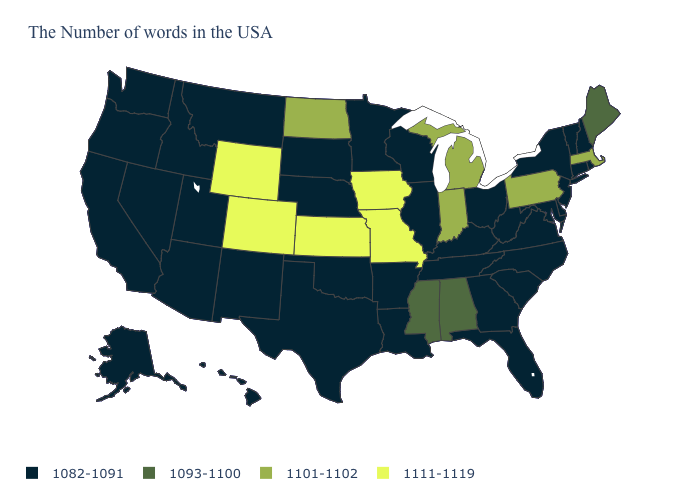What is the value of North Dakota?
Quick response, please. 1101-1102. Among the states that border New Hampshire , does Maine have the lowest value?
Write a very short answer. No. Which states have the lowest value in the USA?
Short answer required. Rhode Island, New Hampshire, Vermont, Connecticut, New York, New Jersey, Delaware, Maryland, Virginia, North Carolina, South Carolina, West Virginia, Ohio, Florida, Georgia, Kentucky, Tennessee, Wisconsin, Illinois, Louisiana, Arkansas, Minnesota, Nebraska, Oklahoma, Texas, South Dakota, New Mexico, Utah, Montana, Arizona, Idaho, Nevada, California, Washington, Oregon, Alaska, Hawaii. Does the first symbol in the legend represent the smallest category?
Give a very brief answer. Yes. What is the value of Alaska?
Keep it brief. 1082-1091. What is the value of Illinois?
Keep it brief. 1082-1091. Which states have the lowest value in the USA?
Be succinct. Rhode Island, New Hampshire, Vermont, Connecticut, New York, New Jersey, Delaware, Maryland, Virginia, North Carolina, South Carolina, West Virginia, Ohio, Florida, Georgia, Kentucky, Tennessee, Wisconsin, Illinois, Louisiana, Arkansas, Minnesota, Nebraska, Oklahoma, Texas, South Dakota, New Mexico, Utah, Montana, Arizona, Idaho, Nevada, California, Washington, Oregon, Alaska, Hawaii. What is the value of Washington?
Keep it brief. 1082-1091. Name the states that have a value in the range 1082-1091?
Short answer required. Rhode Island, New Hampshire, Vermont, Connecticut, New York, New Jersey, Delaware, Maryland, Virginia, North Carolina, South Carolina, West Virginia, Ohio, Florida, Georgia, Kentucky, Tennessee, Wisconsin, Illinois, Louisiana, Arkansas, Minnesota, Nebraska, Oklahoma, Texas, South Dakota, New Mexico, Utah, Montana, Arizona, Idaho, Nevada, California, Washington, Oregon, Alaska, Hawaii. Which states hav the highest value in the Northeast?
Quick response, please. Massachusetts, Pennsylvania. Name the states that have a value in the range 1082-1091?
Concise answer only. Rhode Island, New Hampshire, Vermont, Connecticut, New York, New Jersey, Delaware, Maryland, Virginia, North Carolina, South Carolina, West Virginia, Ohio, Florida, Georgia, Kentucky, Tennessee, Wisconsin, Illinois, Louisiana, Arkansas, Minnesota, Nebraska, Oklahoma, Texas, South Dakota, New Mexico, Utah, Montana, Arizona, Idaho, Nevada, California, Washington, Oregon, Alaska, Hawaii. Name the states that have a value in the range 1101-1102?
Quick response, please. Massachusetts, Pennsylvania, Michigan, Indiana, North Dakota. What is the value of Washington?
Quick response, please. 1082-1091. What is the highest value in the USA?
Answer briefly. 1111-1119. What is the lowest value in the West?
Answer briefly. 1082-1091. 